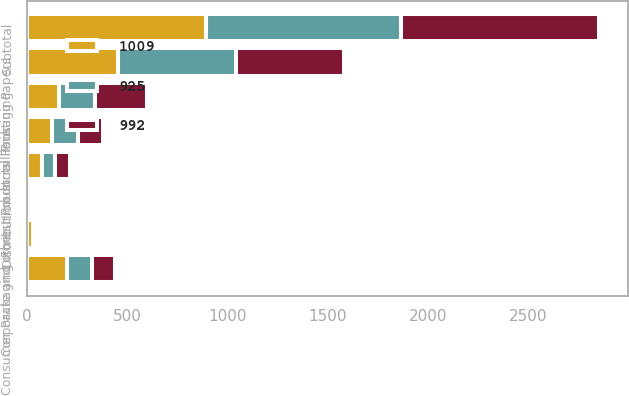<chart> <loc_0><loc_0><loc_500><loc_500><stacked_bar_chart><ecel><fcel>In millions<fcel>Printing Papers<fcel>Industrial Packaging<fcel>Consumer Packaging<fcel>Distribution<fcel>Forest Products<fcel>Subtotal<fcel>Corporate and other<nl><fcel>992<fcel>126<fcel>537<fcel>257<fcel>116<fcel>6<fcel>72<fcel>988<fcel>21<nl><fcel>925<fcel>126<fcel>592<fcel>180<fcel>126<fcel>9<fcel>66<fcel>973<fcel>19<nl><fcel>1009<fcel>126<fcel>453<fcel>161<fcel>198<fcel>5<fcel>76<fcel>893<fcel>32<nl></chart> 